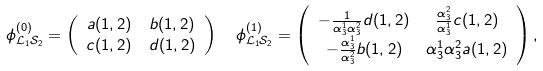<formula> <loc_0><loc_0><loc_500><loc_500>& \phi ^ { ( 0 ) } _ { \mathcal { L } _ { 1 } \mathcal { S } _ { 2 } } = \left ( \begin{array} { c c } a ( 1 , 2 ) & b ( 1 , 2 ) \\ c ( 1 , 2 ) & d ( 1 , 2 ) \end{array} \right ) \quad \phi ^ { ( 1 ) } _ { \mathcal { L } _ { 1 } \mathcal { S } _ { 2 } } = \left ( \begin{array} { c c } - \frac { 1 } { \alpha _ { 3 } ^ { 1 } \alpha _ { 3 } ^ { 2 } } d ( 1 , 2 ) & \frac { \alpha _ { 3 } ^ { 2 } } { \alpha _ { 3 } ^ { 1 } } c ( 1 , 2 ) \\ - \frac { \alpha _ { 3 } ^ { 1 } } { \alpha _ { 3 } ^ { 2 } } b ( 1 , 2 ) & { \alpha _ { 3 } ^ { 1 } \alpha _ { 3 } ^ { 2 } } a ( 1 , 2 ) \end{array} \right ) ,</formula> 